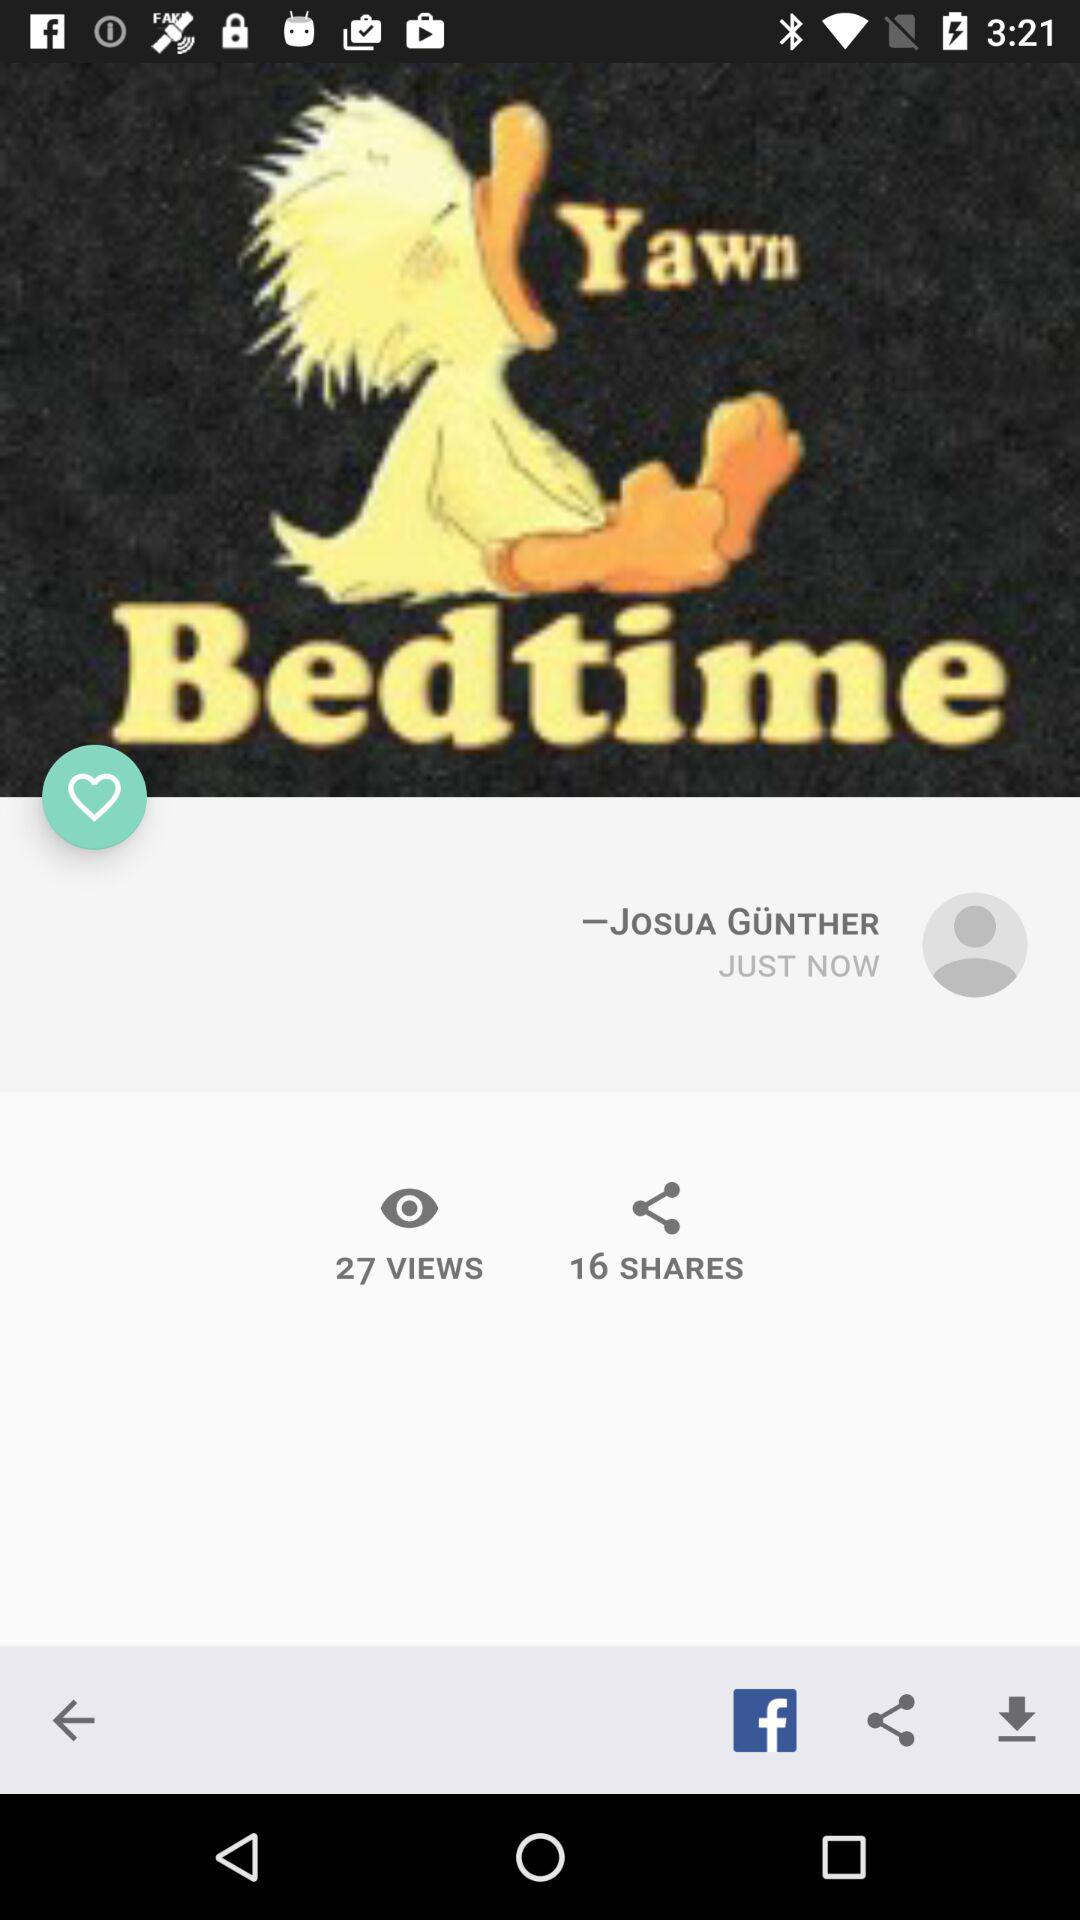How many share are there? There are 16 shares. 